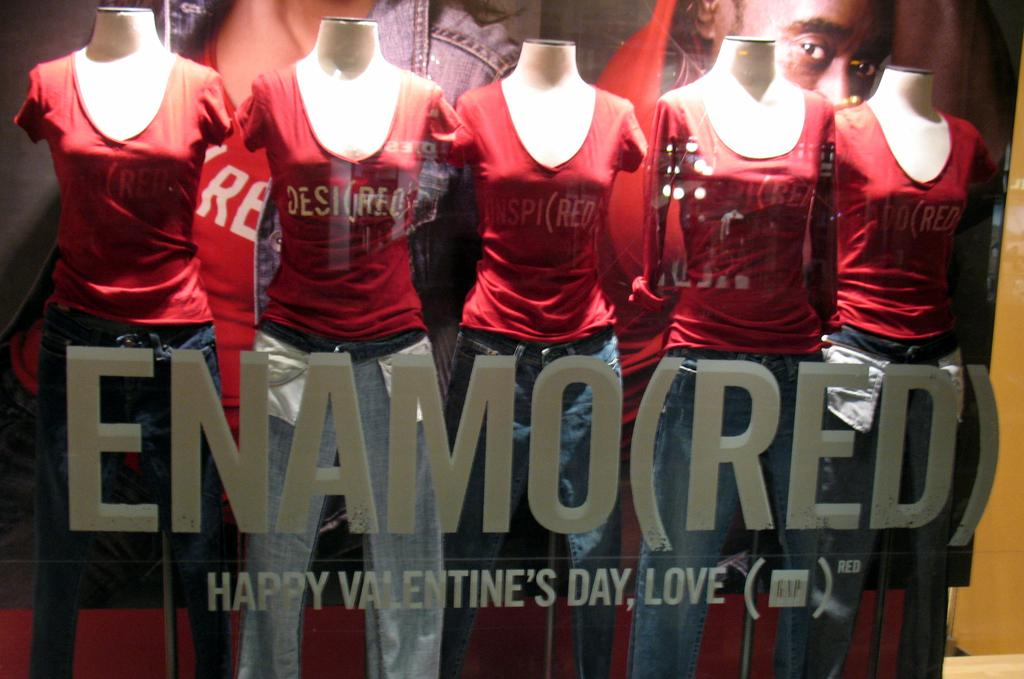Provide a one-sentence caption for the provided image. a group of mannequins sit next to each other as it reads enamored. 